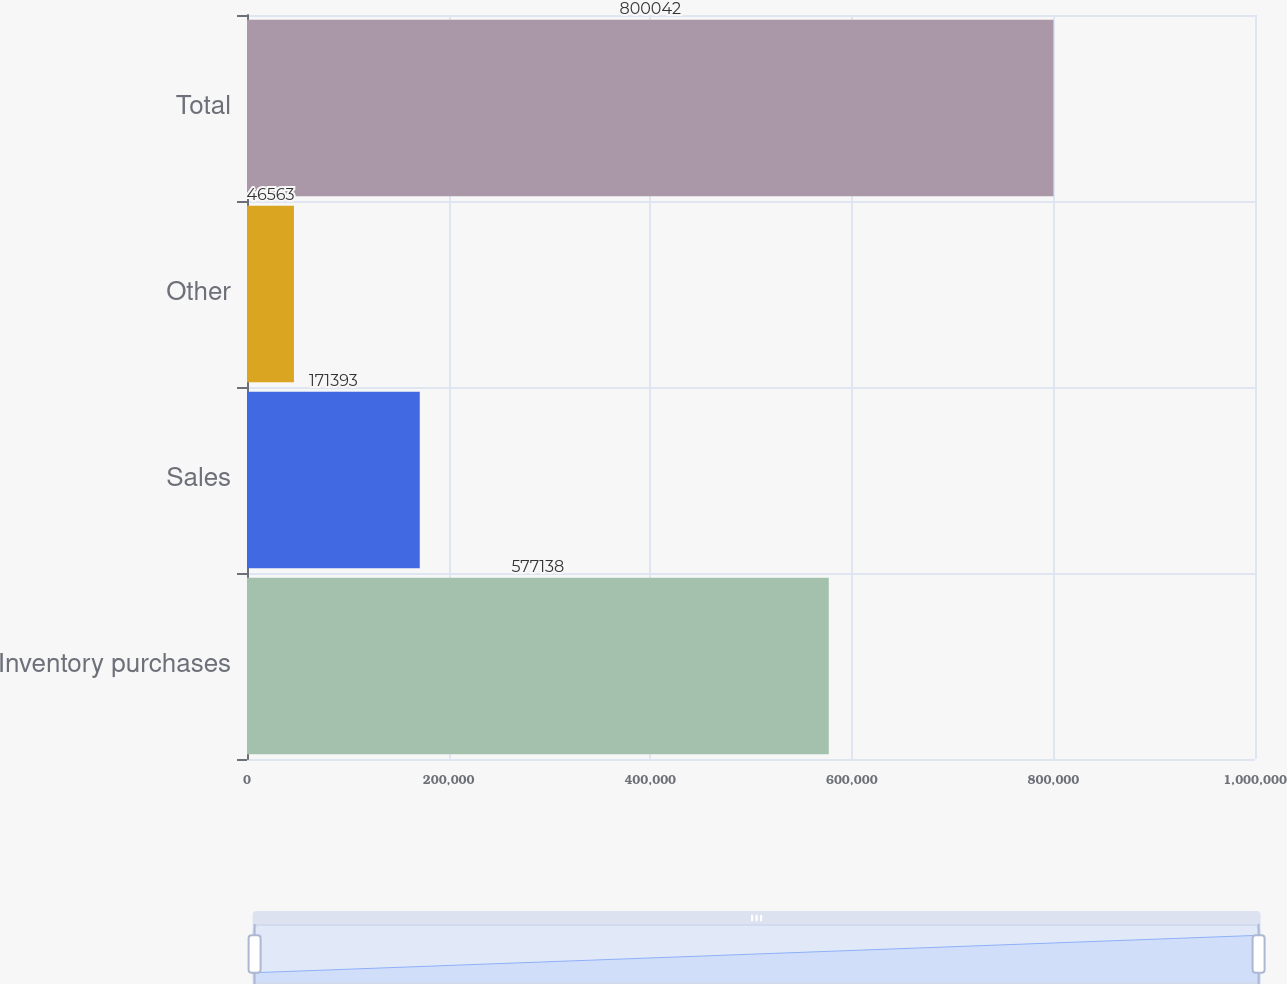<chart> <loc_0><loc_0><loc_500><loc_500><bar_chart><fcel>Inventory purchases<fcel>Sales<fcel>Other<fcel>Total<nl><fcel>577138<fcel>171393<fcel>46563<fcel>800042<nl></chart> 